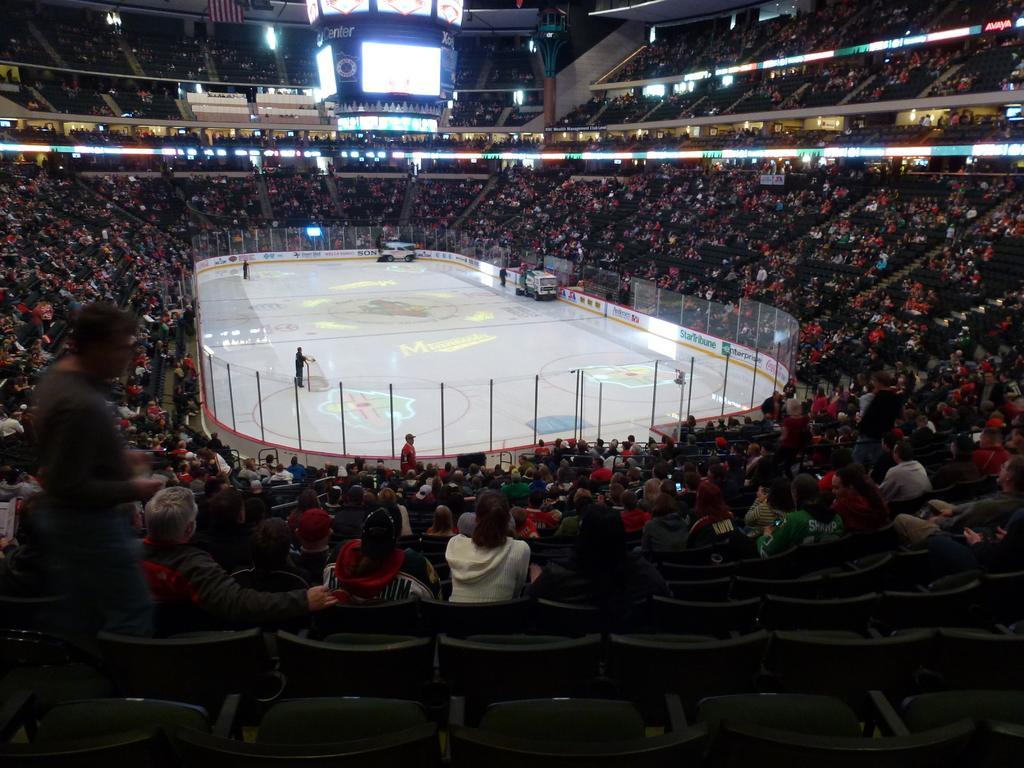Can you describe this image briefly? In the center of the image, we can see some people on the the stage and there is a fence, some vehicles. In the background, there is a crowd. At the top, there are lights and boards and at the bottom, there are chairs. 